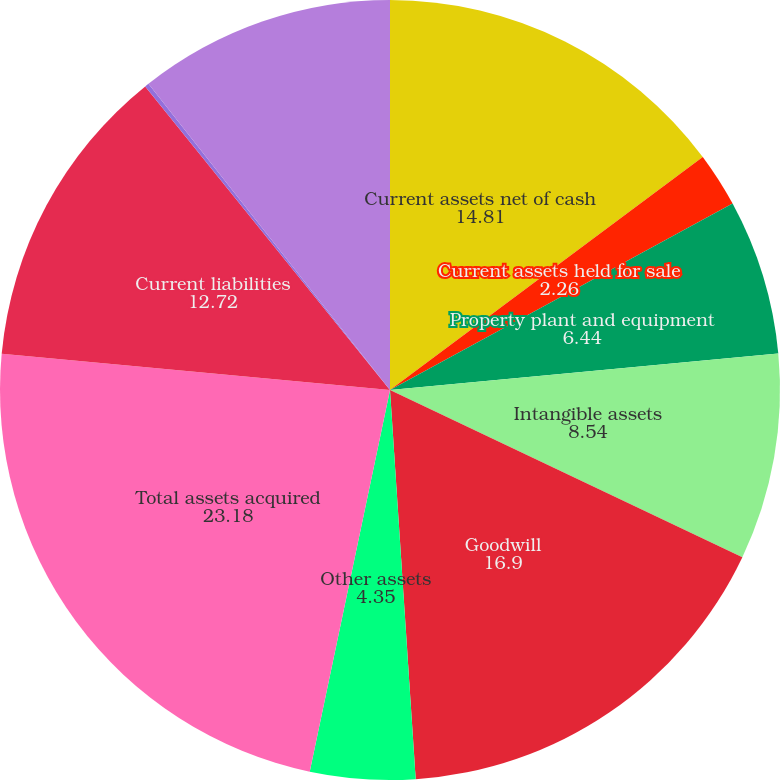Convert chart to OTSL. <chart><loc_0><loc_0><loc_500><loc_500><pie_chart><fcel>Current assets net of cash<fcel>Current assets held for sale<fcel>Property plant and equipment<fcel>Intangible assets<fcel>Goodwill<fcel>Other assets<fcel>Total assets acquired<fcel>Current liabilities<fcel>Current liabilities held for<fcel>Long-term liabilities<nl><fcel>14.81%<fcel>2.26%<fcel>6.44%<fcel>8.54%<fcel>16.9%<fcel>4.35%<fcel>23.18%<fcel>12.72%<fcel>0.17%<fcel>10.63%<nl></chart> 